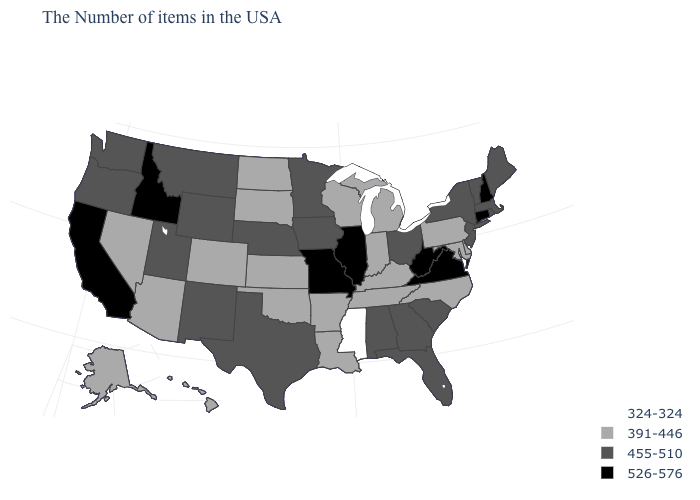Among the states that border New Mexico , which have the lowest value?
Be succinct. Oklahoma, Colorado, Arizona. What is the value of Massachusetts?
Short answer required. 455-510. Among the states that border Vermont , does Massachusetts have the highest value?
Concise answer only. No. What is the highest value in the West ?
Concise answer only. 526-576. What is the value of Washington?
Answer briefly. 455-510. Does Virginia have the highest value in the South?
Be succinct. Yes. What is the value of New Jersey?
Give a very brief answer. 455-510. Does Wyoming have the highest value in the USA?
Write a very short answer. No. What is the highest value in the South ?
Answer briefly. 526-576. What is the value of Virginia?
Short answer required. 526-576. Among the states that border West Virginia , which have the highest value?
Write a very short answer. Virginia. Name the states that have a value in the range 526-576?
Keep it brief. New Hampshire, Connecticut, Virginia, West Virginia, Illinois, Missouri, Idaho, California. Among the states that border New York , does Massachusetts have the highest value?
Concise answer only. No. Does Connecticut have the highest value in the USA?
Keep it brief. Yes. What is the lowest value in the MidWest?
Short answer required. 391-446. 